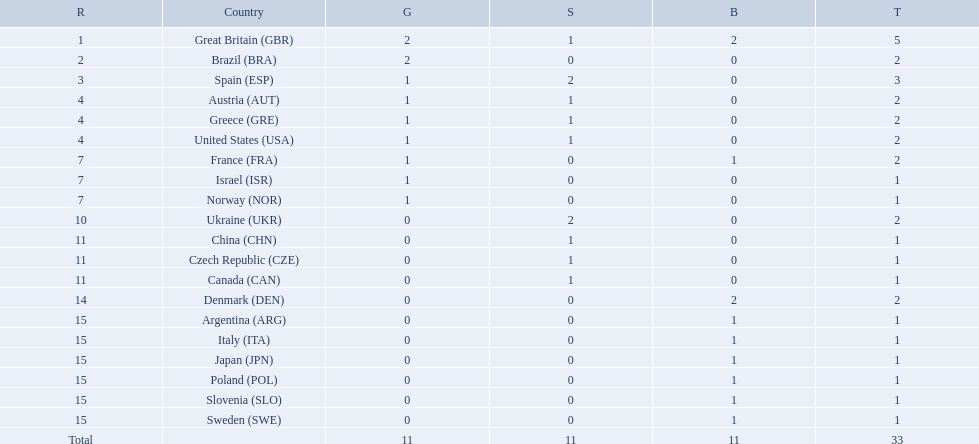How many medals did each country receive? 5, 2, 3, 2, 2, 2, 2, 1, 1, 2, 1, 1, 1, 2, 1, 1, 1, 1, 1, 1. Which country received 3 medals? Spain (ESP). What are all of the countries? Great Britain (GBR), Brazil (BRA), Spain (ESP), Austria (AUT), Greece (GRE), United States (USA), France (FRA), Israel (ISR), Norway (NOR), Ukraine (UKR), China (CHN), Czech Republic (CZE), Canada (CAN), Denmark (DEN), Argentina (ARG), Italy (ITA), Japan (JPN), Poland (POL), Slovenia (SLO), Sweden (SWE). Which ones earned a medal? Great Britain (GBR), Brazil (BRA), Spain (ESP), Austria (AUT), Greece (GRE), United States (USA), France (FRA), Israel (ISR), Norway (NOR), Ukraine (UKR), China (CHN), Czech Republic (CZE), Canada (CAN), Denmark (DEN), Argentina (ARG), Italy (ITA), Japan (JPN), Poland (POL), Slovenia (SLO), Sweden (SWE). Could you help me parse every detail presented in this table? {'header': ['R', 'Country', 'G', 'S', 'B', 'T'], 'rows': [['1', 'Great Britain\xa0(GBR)', '2', '1', '2', '5'], ['2', 'Brazil\xa0(BRA)', '2', '0', '0', '2'], ['3', 'Spain\xa0(ESP)', '1', '2', '0', '3'], ['4', 'Austria\xa0(AUT)', '1', '1', '0', '2'], ['4', 'Greece\xa0(GRE)', '1', '1', '0', '2'], ['4', 'United States\xa0(USA)', '1', '1', '0', '2'], ['7', 'France\xa0(FRA)', '1', '0', '1', '2'], ['7', 'Israel\xa0(ISR)', '1', '0', '0', '1'], ['7', 'Norway\xa0(NOR)', '1', '0', '0', '1'], ['10', 'Ukraine\xa0(UKR)', '0', '2', '0', '2'], ['11', 'China\xa0(CHN)', '0', '1', '0', '1'], ['11', 'Czech Republic\xa0(CZE)', '0', '1', '0', '1'], ['11', 'Canada\xa0(CAN)', '0', '1', '0', '1'], ['14', 'Denmark\xa0(DEN)', '0', '0', '2', '2'], ['15', 'Argentina\xa0(ARG)', '0', '0', '1', '1'], ['15', 'Italy\xa0(ITA)', '0', '0', '1', '1'], ['15', 'Japan\xa0(JPN)', '0', '0', '1', '1'], ['15', 'Poland\xa0(POL)', '0', '0', '1', '1'], ['15', 'Slovenia\xa0(SLO)', '0', '0', '1', '1'], ['15', 'Sweden\xa0(SWE)', '0', '0', '1', '1'], ['Total', '', '11', '11', '11', '33']]} Which countries earned at least 3 medals? Great Britain (GBR), Spain (ESP). Which country earned 3 medals? Spain (ESP). How many medals did spain gain 3. Would you mind parsing the complete table? {'header': ['R', 'Country', 'G', 'S', 'B', 'T'], 'rows': [['1', 'Great Britain\xa0(GBR)', '2', '1', '2', '5'], ['2', 'Brazil\xa0(BRA)', '2', '0', '0', '2'], ['3', 'Spain\xa0(ESP)', '1', '2', '0', '3'], ['4', 'Austria\xa0(AUT)', '1', '1', '0', '2'], ['4', 'Greece\xa0(GRE)', '1', '1', '0', '2'], ['4', 'United States\xa0(USA)', '1', '1', '0', '2'], ['7', 'France\xa0(FRA)', '1', '0', '1', '2'], ['7', 'Israel\xa0(ISR)', '1', '0', '0', '1'], ['7', 'Norway\xa0(NOR)', '1', '0', '0', '1'], ['10', 'Ukraine\xa0(UKR)', '0', '2', '0', '2'], ['11', 'China\xa0(CHN)', '0', '1', '0', '1'], ['11', 'Czech Republic\xa0(CZE)', '0', '1', '0', '1'], ['11', 'Canada\xa0(CAN)', '0', '1', '0', '1'], ['14', 'Denmark\xa0(DEN)', '0', '0', '2', '2'], ['15', 'Argentina\xa0(ARG)', '0', '0', '1', '1'], ['15', 'Italy\xa0(ITA)', '0', '0', '1', '1'], ['15', 'Japan\xa0(JPN)', '0', '0', '1', '1'], ['15', 'Poland\xa0(POL)', '0', '0', '1', '1'], ['15', 'Slovenia\xa0(SLO)', '0', '0', '1', '1'], ['15', 'Sweden\xa0(SWE)', '0', '0', '1', '1'], ['Total', '', '11', '11', '11', '33']]} Only country that got more medals? Spain (ESP). 